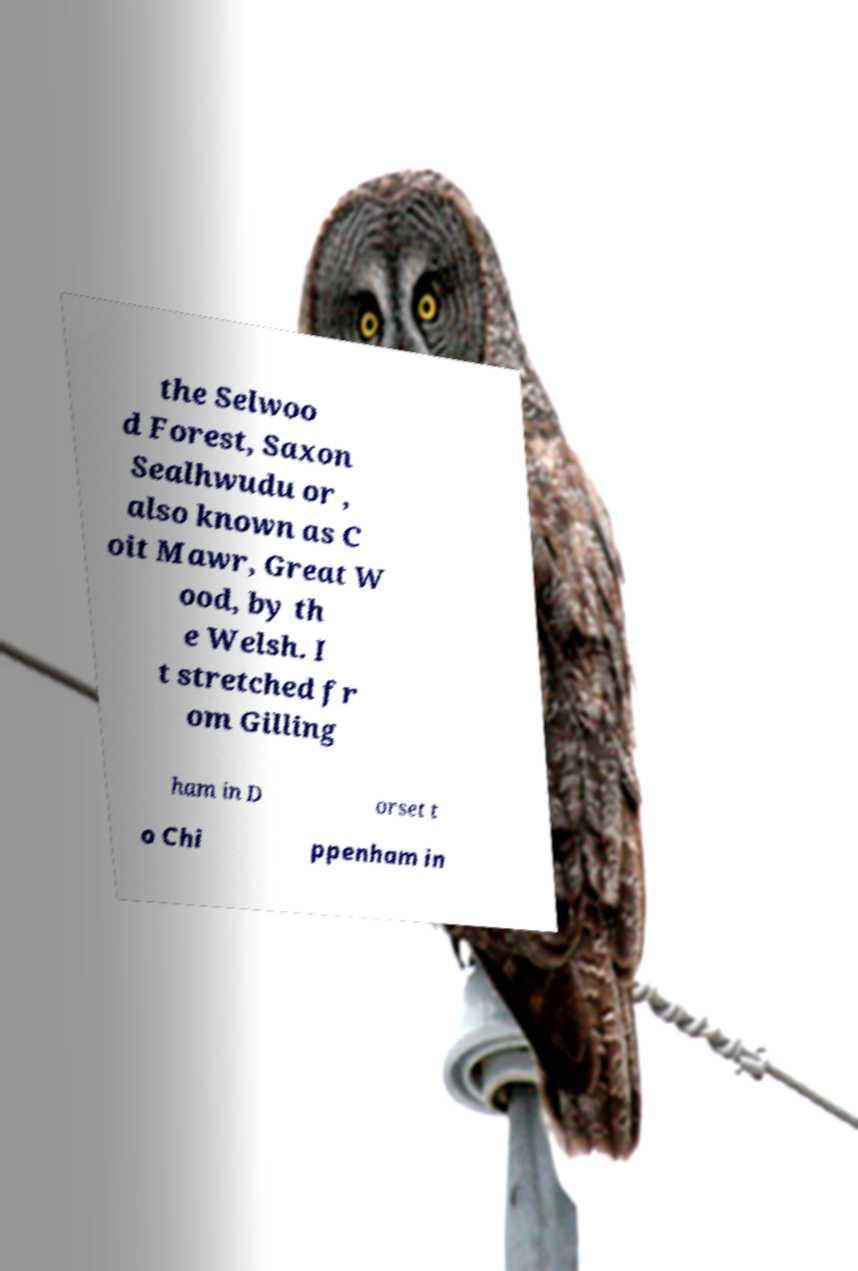I need the written content from this picture converted into text. Can you do that? the Selwoo d Forest, Saxon Sealhwudu or , also known as C oit Mawr, Great W ood, by th e Welsh. I t stretched fr om Gilling ham in D orset t o Chi ppenham in 